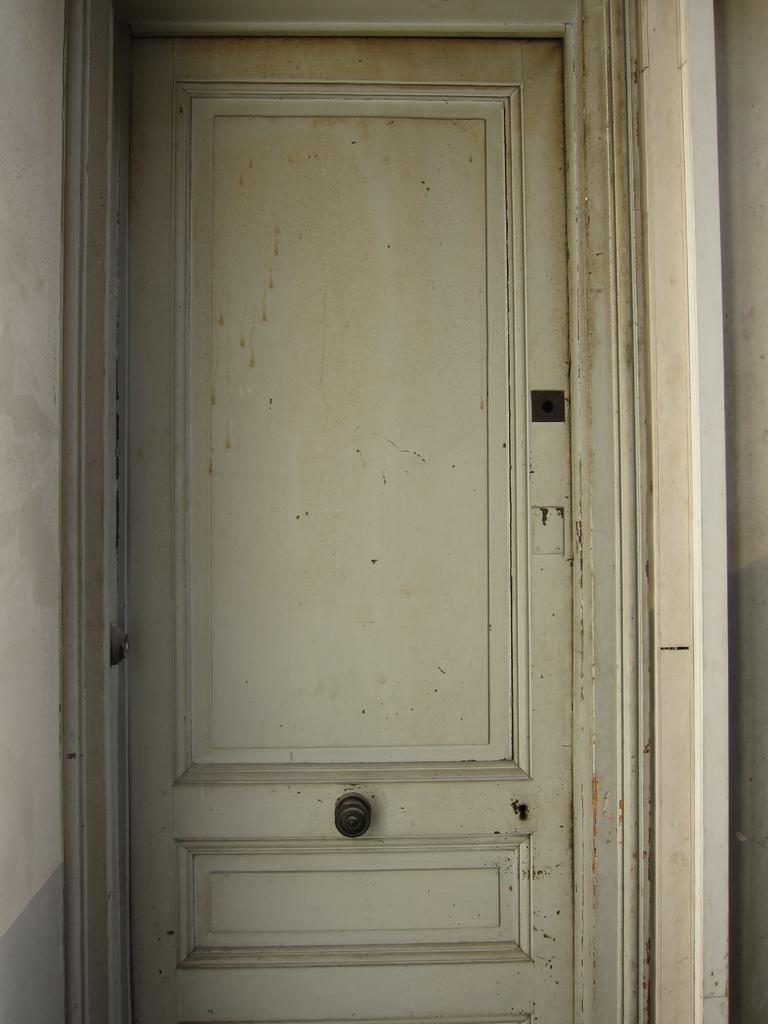What color is the door in the image? The door in the image is white. What is the color of the knob on the door? The knob on the door is black. What color are the walls surrounding the door? The walls on either side of the door are white. How many trees can be seen through the door in the image? There are no trees visible through the door in the image. 